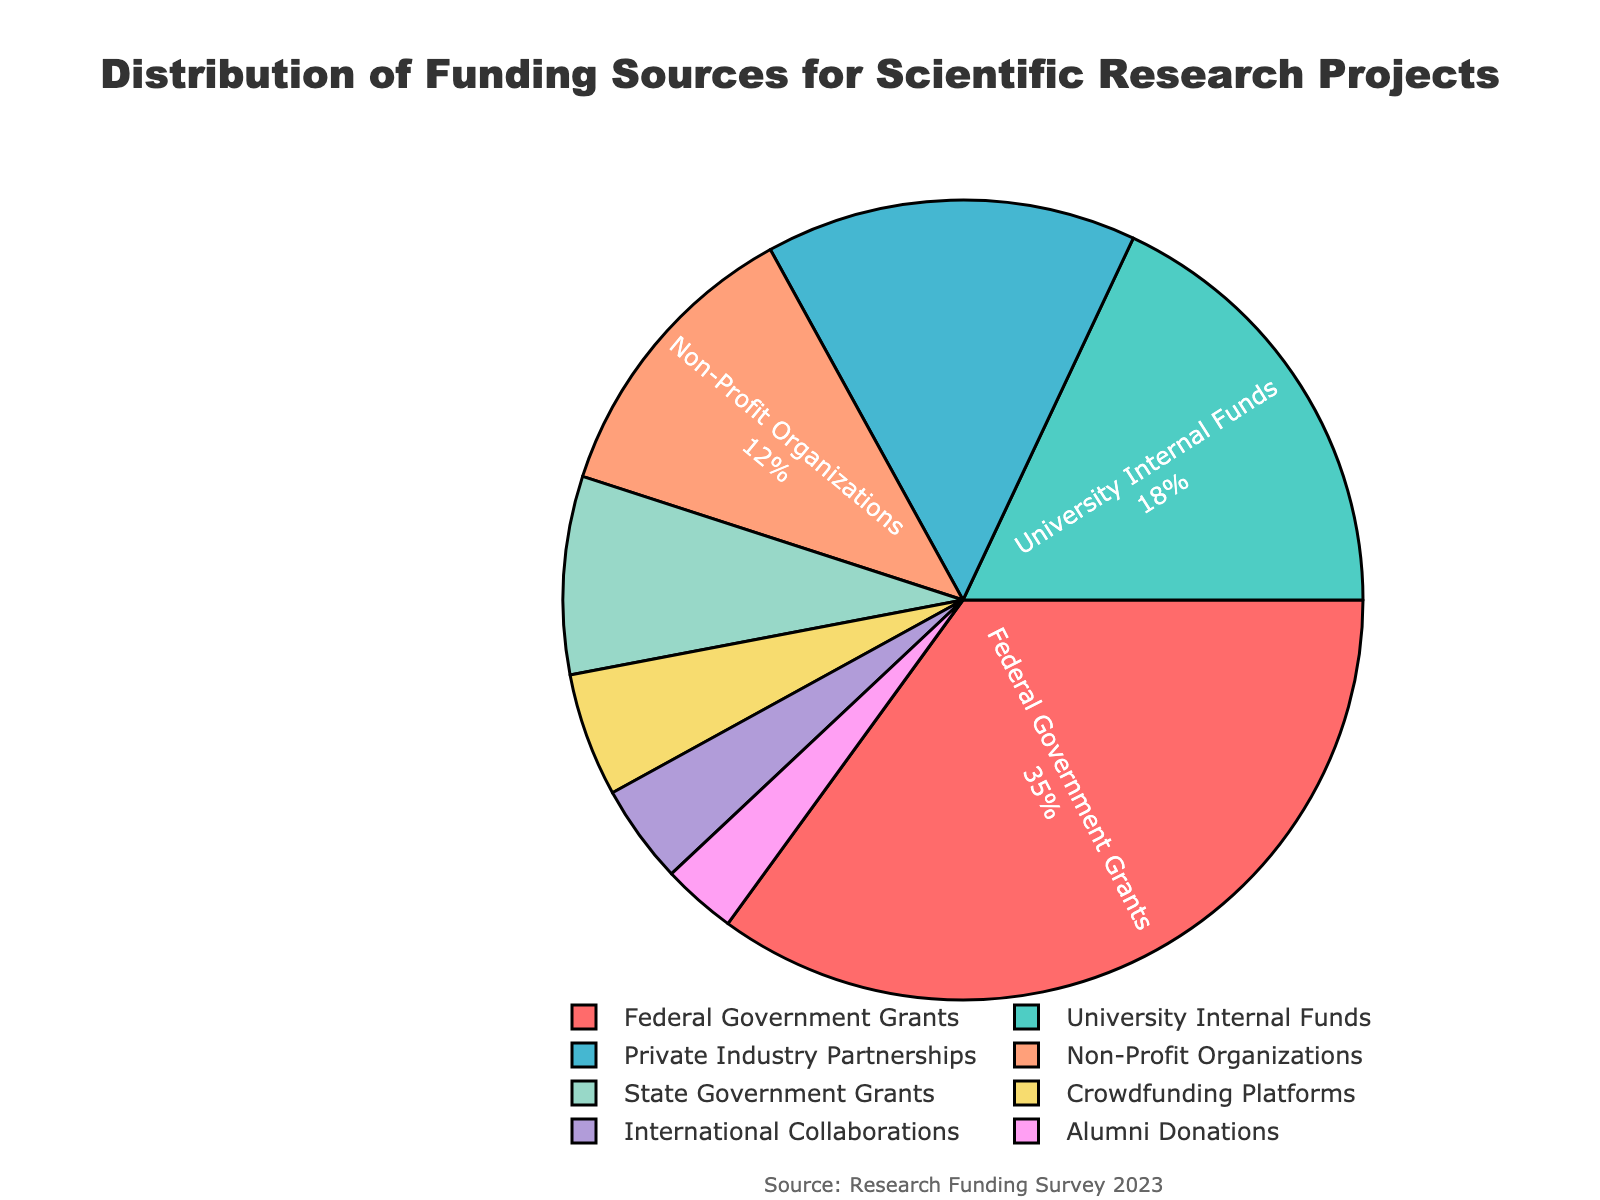What percentage of funding comes from the Federal Government Grants? The Federal Government Grants slice is explicitly labeled in the pie chart with its percentage.
Answer: 35% Which funding source contributes the least amount of funding? Look for the smallest slice in the pie chart, which shows the smallest percentage.
Answer: Alumni Donations How much larger is the percentage of funding from Private Industry Partnerships compared to Crowdfunding Platforms? Subtract the percentage of Crowdfunding Platforms from the percentage of Private Industry Partnerships: 15% - 5%.
Answer: 10% What are the combined percentage contributions of University Internal Funds and Non-Profit Organizations? Add the percentages for University Internal Funds and Non-Profit Organizations: 18% + 12%.
Answer: 30% Which funding sources contribute more than 15% of the overall funding? Identify slices with percentages greater than 15% by looking at the labels: Federal Government Grants (35%) and University Internal Funds (18%).
Answer: Federal Government Grants, University Internal Funds By how much does the percentage of funding from State Government Grants differ from International Collaborations? Subtract the percentage of International Collaborations from the percentage of State Government Grants: 8% - 4%.
Answer: 4% What is the total percentage of funding contributed by government sources (Federal and State)? Add the percentages for Federal Government Grants and State Government Grants: 35% + 8%.
Answer: 43% What color represents the funding source from Non-Profit Organizations in the pie chart? Identify the color of the slice labeled "Non-Profit Organizations".
Answer: Light green (or use the specific shade if visible) Are any funding sources contributing an equal percentage? Compare the percentages in the pie chart to see if any are the same.
Answer: No What is the percentage difference between University Internal Funds and Private Industry Partnerships? Subtract the percentage of Private Industry Partnerships from University Internal Funds: 18% - 15%.
Answer: 3% 